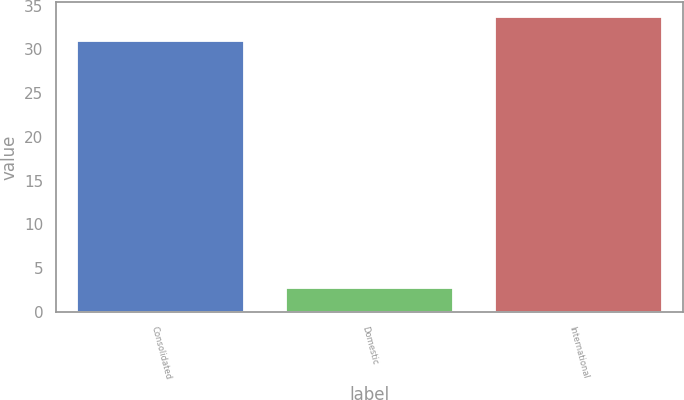<chart> <loc_0><loc_0><loc_500><loc_500><bar_chart><fcel>Consolidated<fcel>Domestic<fcel>International<nl><fcel>30.9<fcel>2.7<fcel>33.72<nl></chart> 